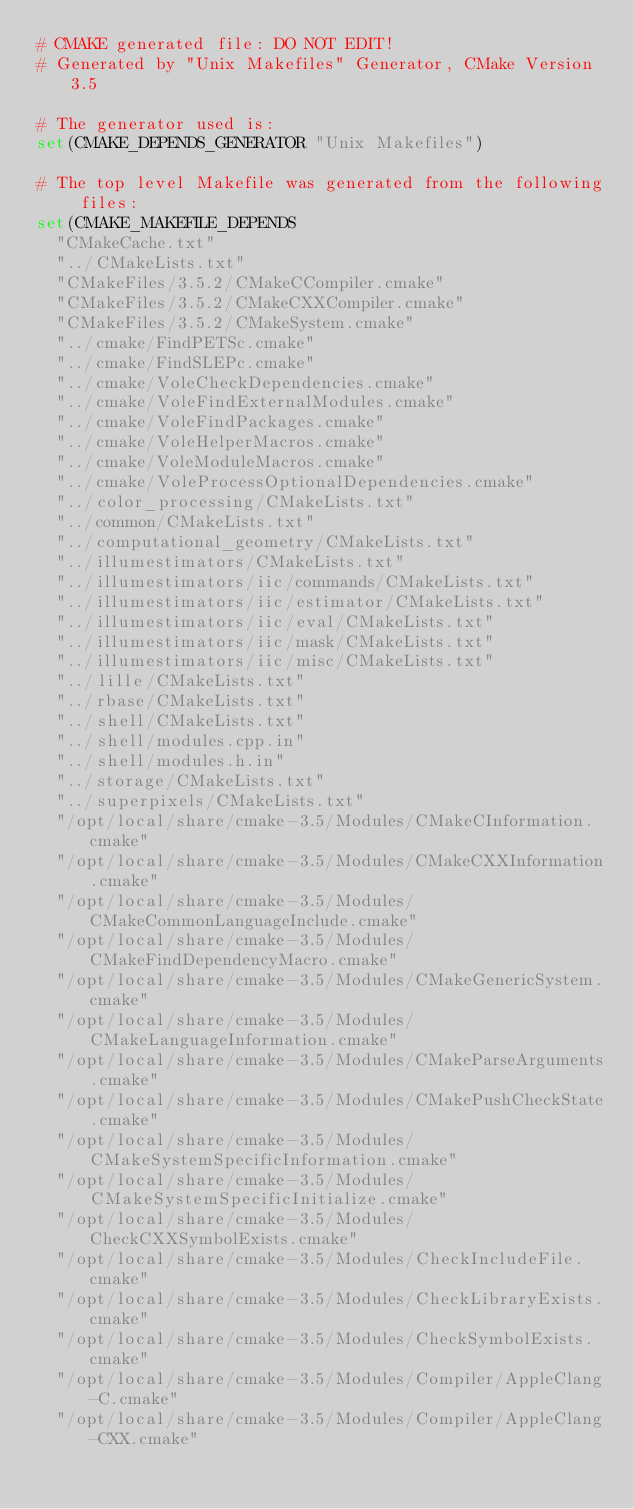Convert code to text. <code><loc_0><loc_0><loc_500><loc_500><_CMake_># CMAKE generated file: DO NOT EDIT!
# Generated by "Unix Makefiles" Generator, CMake Version 3.5

# The generator used is:
set(CMAKE_DEPENDS_GENERATOR "Unix Makefiles")

# The top level Makefile was generated from the following files:
set(CMAKE_MAKEFILE_DEPENDS
  "CMakeCache.txt"
  "../CMakeLists.txt"
  "CMakeFiles/3.5.2/CMakeCCompiler.cmake"
  "CMakeFiles/3.5.2/CMakeCXXCompiler.cmake"
  "CMakeFiles/3.5.2/CMakeSystem.cmake"
  "../cmake/FindPETSc.cmake"
  "../cmake/FindSLEPc.cmake"
  "../cmake/VoleCheckDependencies.cmake"
  "../cmake/VoleFindExternalModules.cmake"
  "../cmake/VoleFindPackages.cmake"
  "../cmake/VoleHelperMacros.cmake"
  "../cmake/VoleModuleMacros.cmake"
  "../cmake/VoleProcessOptionalDependencies.cmake"
  "../color_processing/CMakeLists.txt"
  "../common/CMakeLists.txt"
  "../computational_geometry/CMakeLists.txt"
  "../illumestimators/CMakeLists.txt"
  "../illumestimators/iic/commands/CMakeLists.txt"
  "../illumestimators/iic/estimator/CMakeLists.txt"
  "../illumestimators/iic/eval/CMakeLists.txt"
  "../illumestimators/iic/mask/CMakeLists.txt"
  "../illumestimators/iic/misc/CMakeLists.txt"
  "../lille/CMakeLists.txt"
  "../rbase/CMakeLists.txt"
  "../shell/CMakeLists.txt"
  "../shell/modules.cpp.in"
  "../shell/modules.h.in"
  "../storage/CMakeLists.txt"
  "../superpixels/CMakeLists.txt"
  "/opt/local/share/cmake-3.5/Modules/CMakeCInformation.cmake"
  "/opt/local/share/cmake-3.5/Modules/CMakeCXXInformation.cmake"
  "/opt/local/share/cmake-3.5/Modules/CMakeCommonLanguageInclude.cmake"
  "/opt/local/share/cmake-3.5/Modules/CMakeFindDependencyMacro.cmake"
  "/opt/local/share/cmake-3.5/Modules/CMakeGenericSystem.cmake"
  "/opt/local/share/cmake-3.5/Modules/CMakeLanguageInformation.cmake"
  "/opt/local/share/cmake-3.5/Modules/CMakeParseArguments.cmake"
  "/opt/local/share/cmake-3.5/Modules/CMakePushCheckState.cmake"
  "/opt/local/share/cmake-3.5/Modules/CMakeSystemSpecificInformation.cmake"
  "/opt/local/share/cmake-3.5/Modules/CMakeSystemSpecificInitialize.cmake"
  "/opt/local/share/cmake-3.5/Modules/CheckCXXSymbolExists.cmake"
  "/opt/local/share/cmake-3.5/Modules/CheckIncludeFile.cmake"
  "/opt/local/share/cmake-3.5/Modules/CheckLibraryExists.cmake"
  "/opt/local/share/cmake-3.5/Modules/CheckSymbolExists.cmake"
  "/opt/local/share/cmake-3.5/Modules/Compiler/AppleClang-C.cmake"
  "/opt/local/share/cmake-3.5/Modules/Compiler/AppleClang-CXX.cmake"</code> 